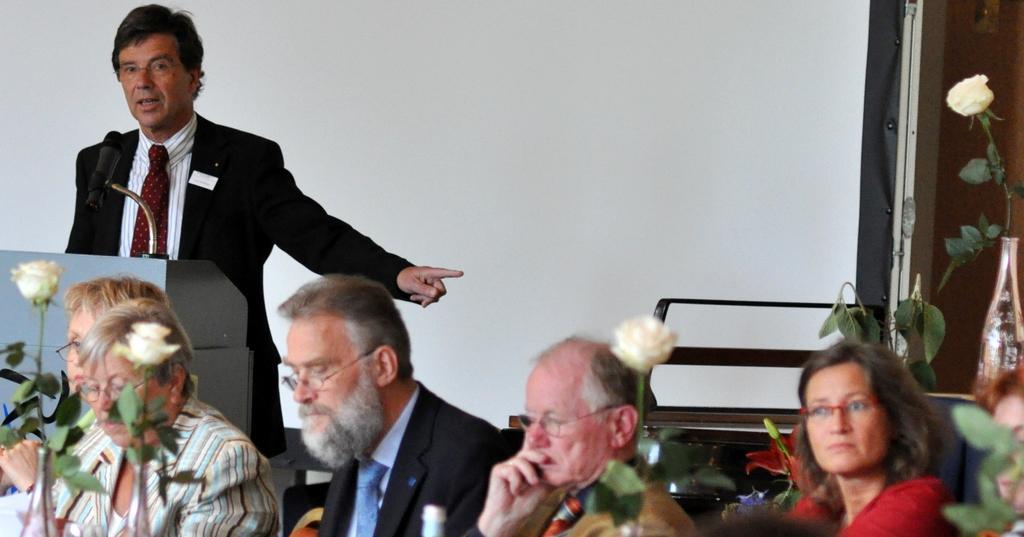Please provide a concise description of this image. In this image, we can see some people sitting and they are wearing specs, at the left side there is a man standing and he is speaking in a microphone, in the background we can see a white color wall. 